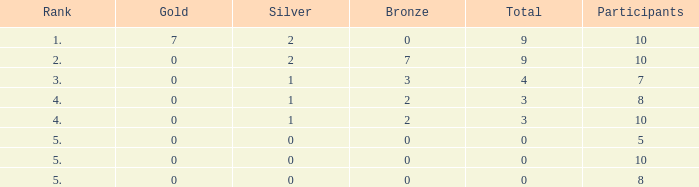What is listed as the highest Gold that also has a Silver that's smaller than 1, and has a Total that's smaller than 0? None. 